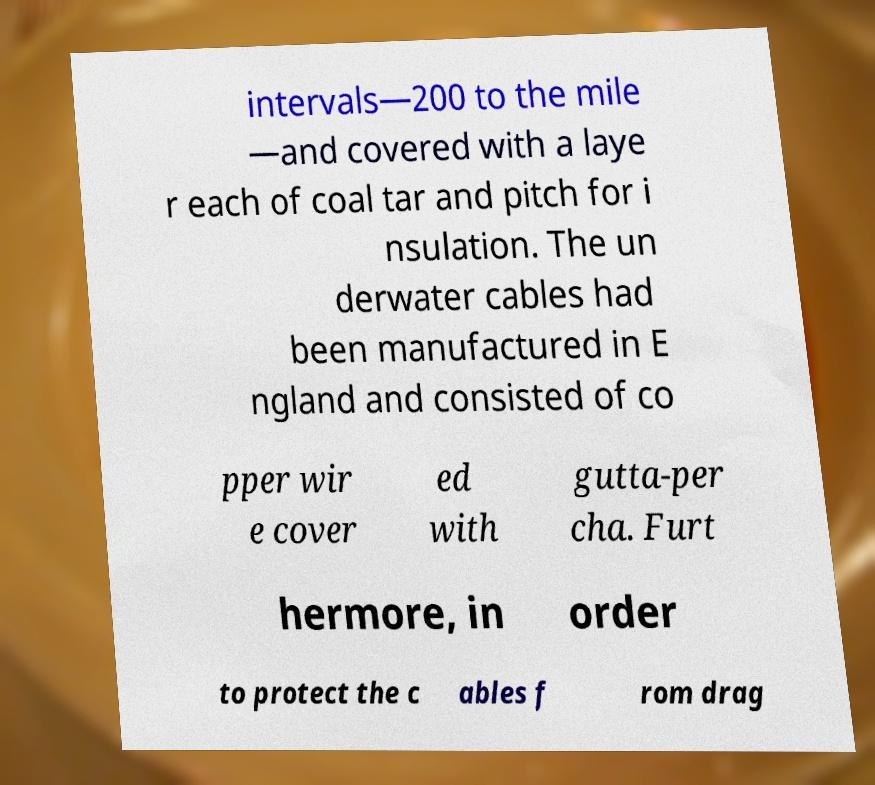Can you read and provide the text displayed in the image?This photo seems to have some interesting text. Can you extract and type it out for me? intervals—200 to the mile —and covered with a laye r each of coal tar and pitch for i nsulation. The un derwater cables had been manufactured in E ngland and consisted of co pper wir e cover ed with gutta-per cha. Furt hermore, in order to protect the c ables f rom drag 